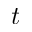<formula> <loc_0><loc_0><loc_500><loc_500>t</formula> 